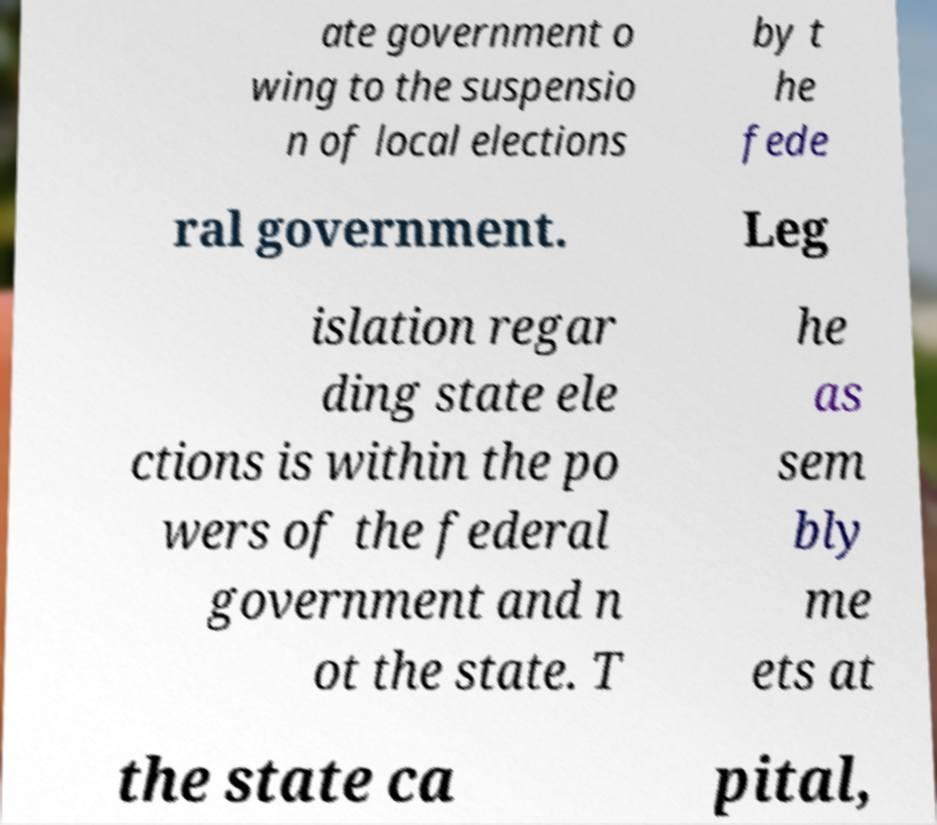What messages or text are displayed in this image? I need them in a readable, typed format. ate government o wing to the suspensio n of local elections by t he fede ral government. Leg islation regar ding state ele ctions is within the po wers of the federal government and n ot the state. T he as sem bly me ets at the state ca pital, 